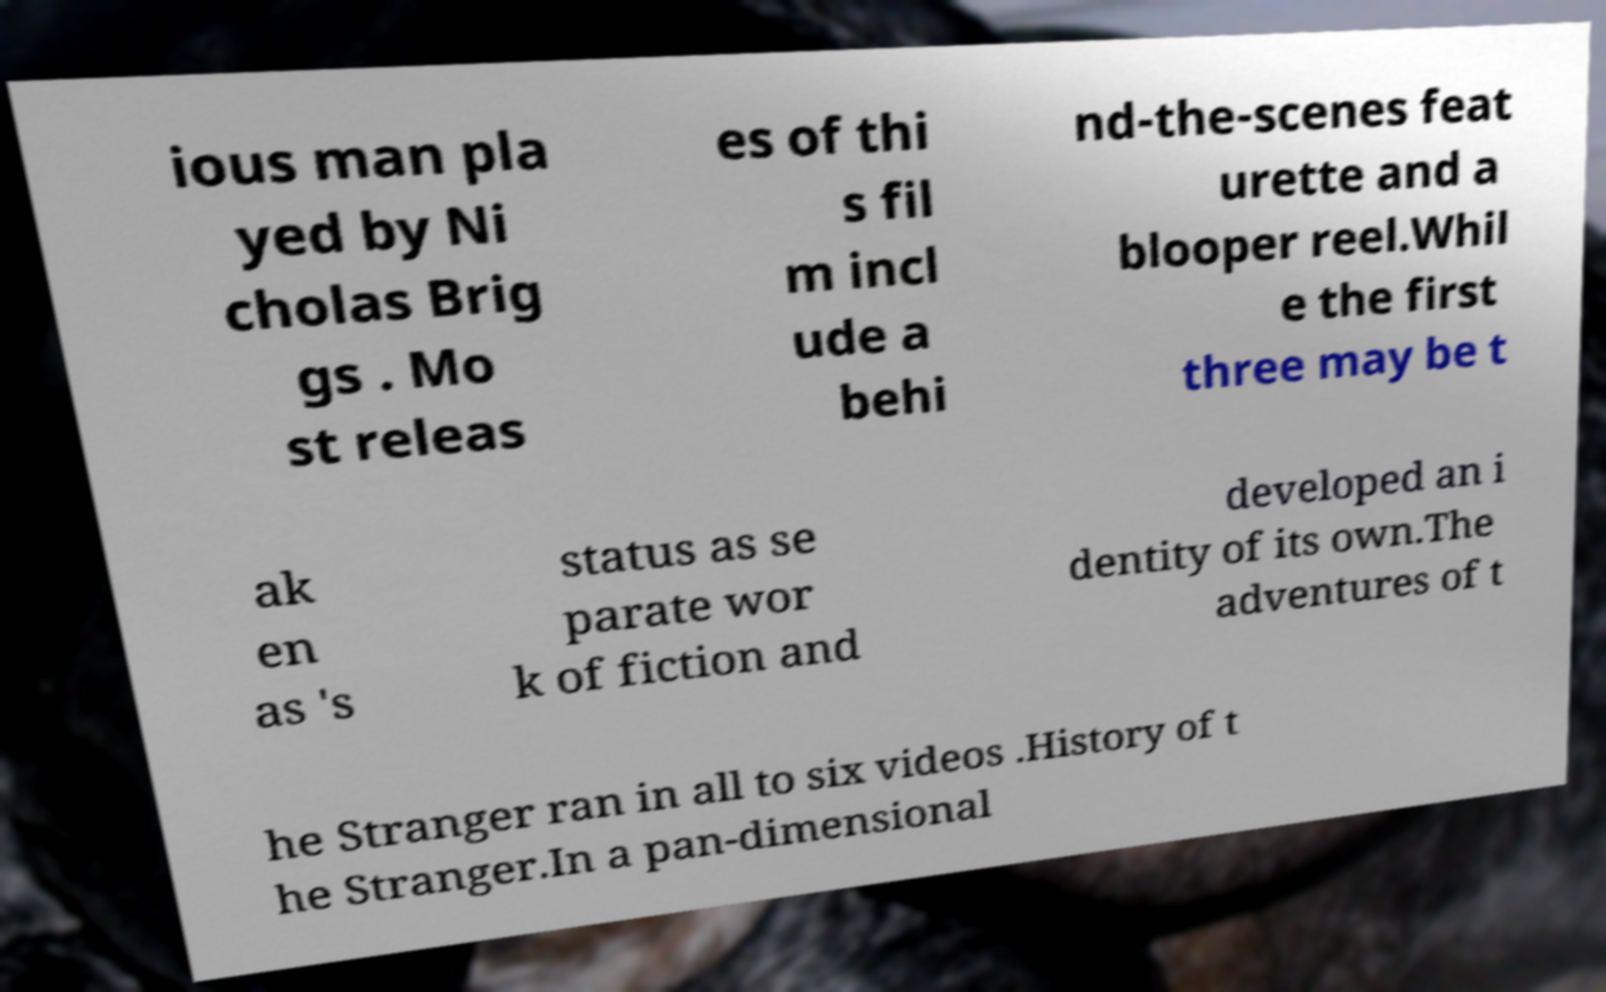What messages or text are displayed in this image? I need them in a readable, typed format. ious man pla yed by Ni cholas Brig gs . Mo st releas es of thi s fil m incl ude a behi nd-the-scenes feat urette and a blooper reel.Whil e the first three may be t ak en as 's status as se parate wor k of fiction and developed an i dentity of its own.The adventures of t he Stranger ran in all to six videos .History of t he Stranger.In a pan-dimensional 